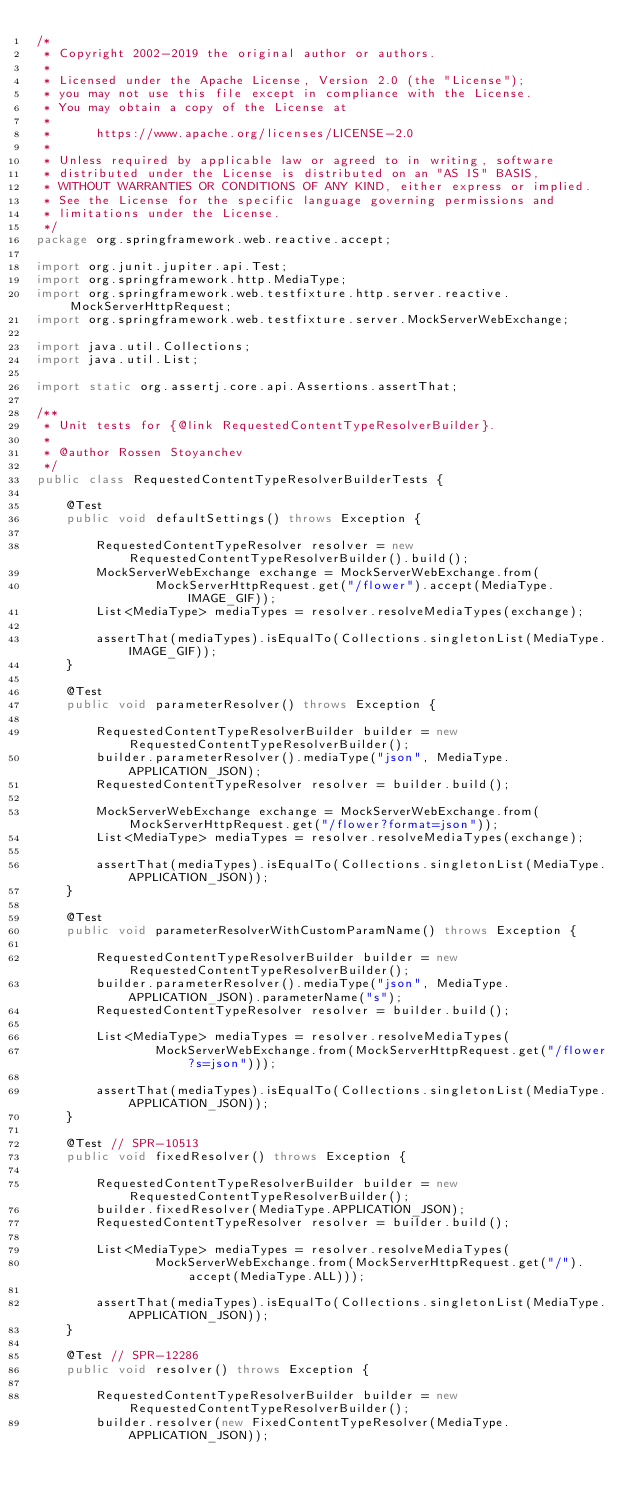Convert code to text. <code><loc_0><loc_0><loc_500><loc_500><_Java_>/*
 * Copyright 2002-2019 the original author or authors.
 *
 * Licensed under the Apache License, Version 2.0 (the "License");
 * you may not use this file except in compliance with the License.
 * You may obtain a copy of the License at
 *
 *      https://www.apache.org/licenses/LICENSE-2.0
 *
 * Unless required by applicable law or agreed to in writing, software
 * distributed under the License is distributed on an "AS IS" BASIS,
 * WITHOUT WARRANTIES OR CONDITIONS OF ANY KIND, either express or implied.
 * See the License for the specific language governing permissions and
 * limitations under the License.
 */
package org.springframework.web.reactive.accept;

import org.junit.jupiter.api.Test;
import org.springframework.http.MediaType;
import org.springframework.web.testfixture.http.server.reactive.MockServerHttpRequest;
import org.springframework.web.testfixture.server.MockServerWebExchange;

import java.util.Collections;
import java.util.List;

import static org.assertj.core.api.Assertions.assertThat;

/**
 * Unit tests for {@link RequestedContentTypeResolverBuilder}.
 *
 * @author Rossen Stoyanchev
 */
public class RequestedContentTypeResolverBuilderTests {

	@Test
	public void defaultSettings() throws Exception {

		RequestedContentTypeResolver resolver = new RequestedContentTypeResolverBuilder().build();
		MockServerWebExchange exchange = MockServerWebExchange.from(
				MockServerHttpRequest.get("/flower").accept(MediaType.IMAGE_GIF));
		List<MediaType> mediaTypes = resolver.resolveMediaTypes(exchange);

		assertThat(mediaTypes).isEqualTo(Collections.singletonList(MediaType.IMAGE_GIF));
	}

	@Test
	public void parameterResolver() throws Exception {

		RequestedContentTypeResolverBuilder builder = new RequestedContentTypeResolverBuilder();
		builder.parameterResolver().mediaType("json", MediaType.APPLICATION_JSON);
		RequestedContentTypeResolver resolver = builder.build();

		MockServerWebExchange exchange = MockServerWebExchange.from(MockServerHttpRequest.get("/flower?format=json"));
		List<MediaType> mediaTypes = resolver.resolveMediaTypes(exchange);

		assertThat(mediaTypes).isEqualTo(Collections.singletonList(MediaType.APPLICATION_JSON));
	}

	@Test
	public void parameterResolverWithCustomParamName() throws Exception {

		RequestedContentTypeResolverBuilder builder = new RequestedContentTypeResolverBuilder();
		builder.parameterResolver().mediaType("json", MediaType.APPLICATION_JSON).parameterName("s");
		RequestedContentTypeResolver resolver = builder.build();

		List<MediaType> mediaTypes = resolver.resolveMediaTypes(
				MockServerWebExchange.from(MockServerHttpRequest.get("/flower?s=json")));

		assertThat(mediaTypes).isEqualTo(Collections.singletonList(MediaType.APPLICATION_JSON));
	}

	@Test // SPR-10513
	public void fixedResolver() throws Exception {

		RequestedContentTypeResolverBuilder builder = new RequestedContentTypeResolverBuilder();
		builder.fixedResolver(MediaType.APPLICATION_JSON);
		RequestedContentTypeResolver resolver = builder.build();

		List<MediaType> mediaTypes = resolver.resolveMediaTypes(
				MockServerWebExchange.from(MockServerHttpRequest.get("/").accept(MediaType.ALL)));

		assertThat(mediaTypes).isEqualTo(Collections.singletonList(MediaType.APPLICATION_JSON));
	}

	@Test // SPR-12286
	public void resolver() throws Exception {

		RequestedContentTypeResolverBuilder builder = new RequestedContentTypeResolverBuilder();
		builder.resolver(new FixedContentTypeResolver(MediaType.APPLICATION_JSON));</code> 